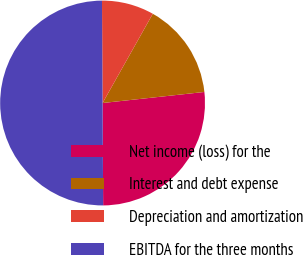<chart> <loc_0><loc_0><loc_500><loc_500><pie_chart><fcel>Net income (loss) for the<fcel>Interest and debt expense<fcel>Depreciation and amortization<fcel>EBITDA for the three months<nl><fcel>26.63%<fcel>15.12%<fcel>8.25%<fcel>50.0%<nl></chart> 